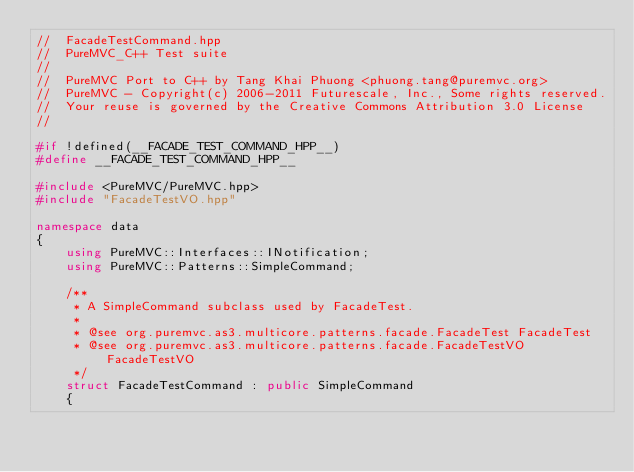<code> <loc_0><loc_0><loc_500><loc_500><_C++_>//  FacadeTestCommand.hpp
//  PureMVC_C++ Test suite
//
//  PureMVC Port to C++ by Tang Khai Phuong <phuong.tang@puremvc.org>
//  PureMVC - Copyright(c) 2006-2011 Futurescale, Inc., Some rights reserved.
//  Your reuse is governed by the Creative Commons Attribution 3.0 License
//

#if !defined(__FACADE_TEST_COMMAND_HPP__)
#define __FACADE_TEST_COMMAND_HPP__

#include <PureMVC/PureMVC.hpp>
#include "FacadeTestVO.hpp"

namespace data
{
    using PureMVC::Interfaces::INotification;
    using PureMVC::Patterns::SimpleCommand;

    /**
     * A SimpleCommand subclass used by FacadeTest.
     *
     * @see org.puremvc.as3.multicore.patterns.facade.FacadeTest FacadeTest
     * @see org.puremvc.as3.multicore.patterns.facade.FacadeTestVO FacadeTestVO
     */
    struct FacadeTestCommand : public SimpleCommand
    {</code> 